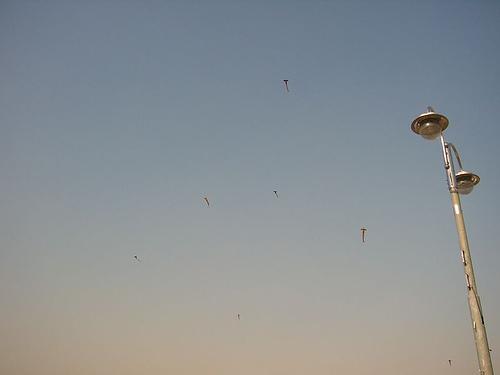How is the sky?
Write a very short answer. Clear. Is this a fun activity?
Concise answer only. Yes. Is there a visible traffic light in this photograph?
Write a very short answer. No. Is this a nice sunset?
Answer briefly. No. How is the weather?
Answer briefly. Clear. What is hanging from the sky?
Be succinct. Kites. Is the sky cloudy?
Give a very brief answer. No. Is this a sign?
Keep it brief. No. What is the object on the right side of the image that contains bulbs?
Quick response, please. Street lights. Is a light on?
Keep it brief. No. 